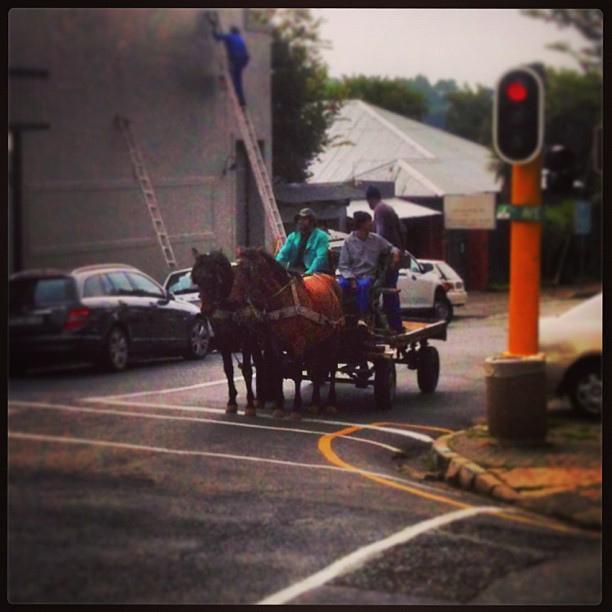What color is the big horse to the right with the flat cart behind it?
Indicate the correct response by choosing from the four available options to answer the question.
Options: Chestnut, white, black, yellow. Chestnut. 